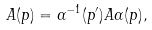<formula> <loc_0><loc_0><loc_500><loc_500>A ( p ) = \alpha ^ { - 1 } ( p ^ { \prime } ) A \alpha ( p ) ,</formula> 